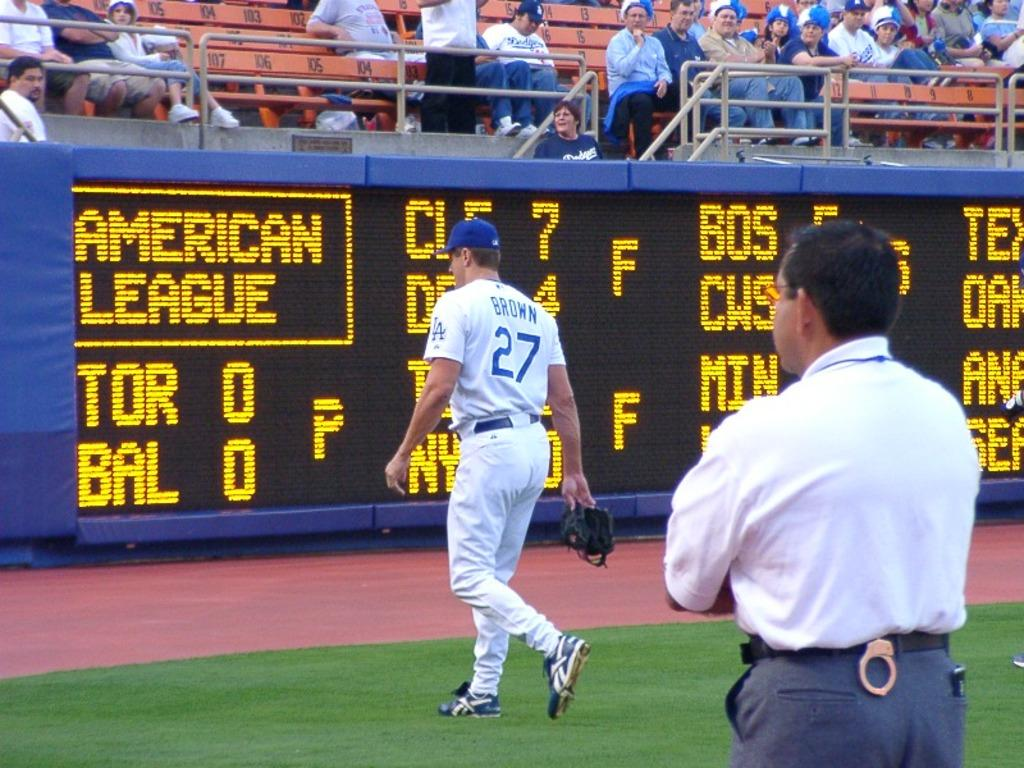<image>
Share a concise interpretation of the image provided. A baseball player wearing the 27 jersey walking down the field 